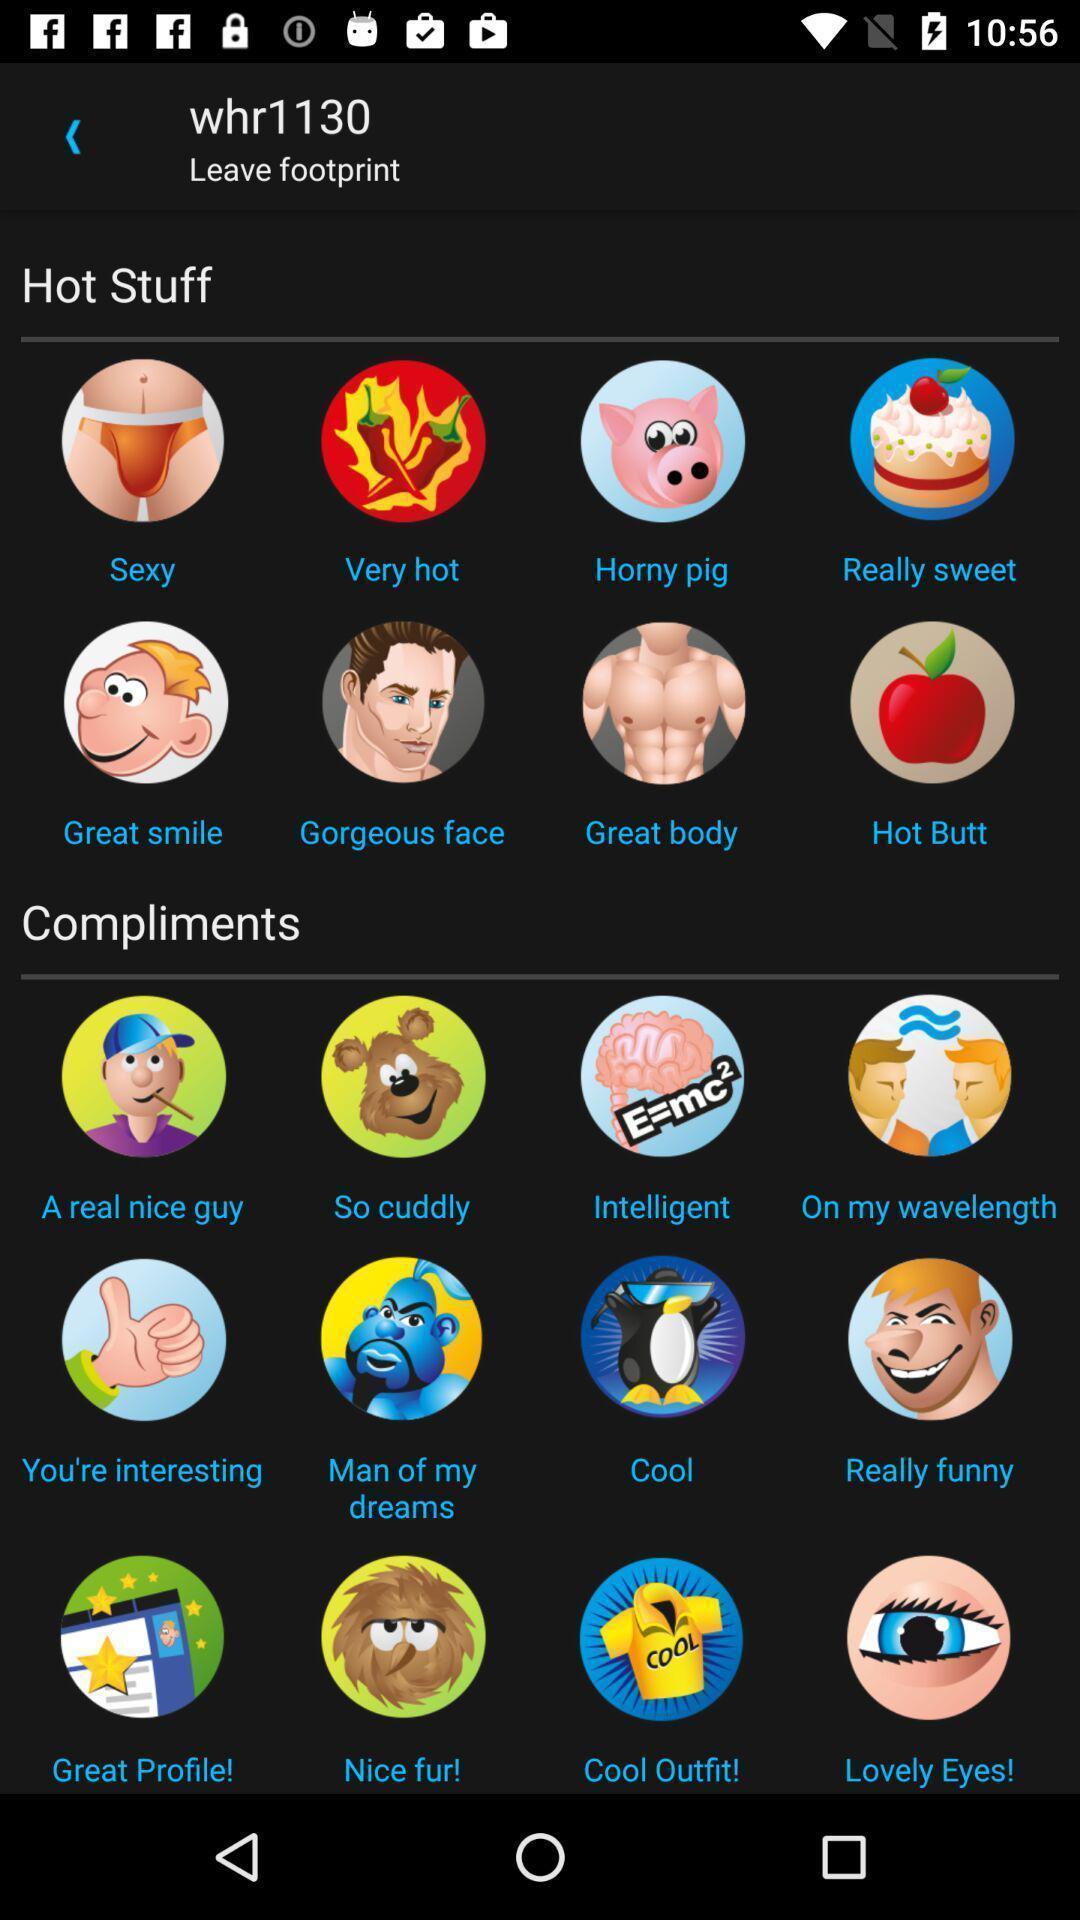What can you discern from this picture? Various stickers displayed of a communication app. 